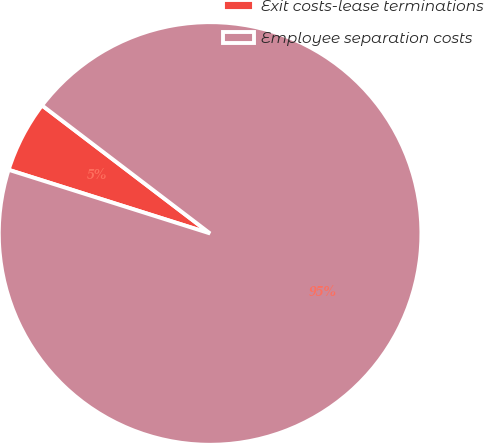<chart> <loc_0><loc_0><loc_500><loc_500><pie_chart><fcel>Exit costs-lease terminations<fcel>Employee separation costs<nl><fcel>5.49%<fcel>94.51%<nl></chart> 